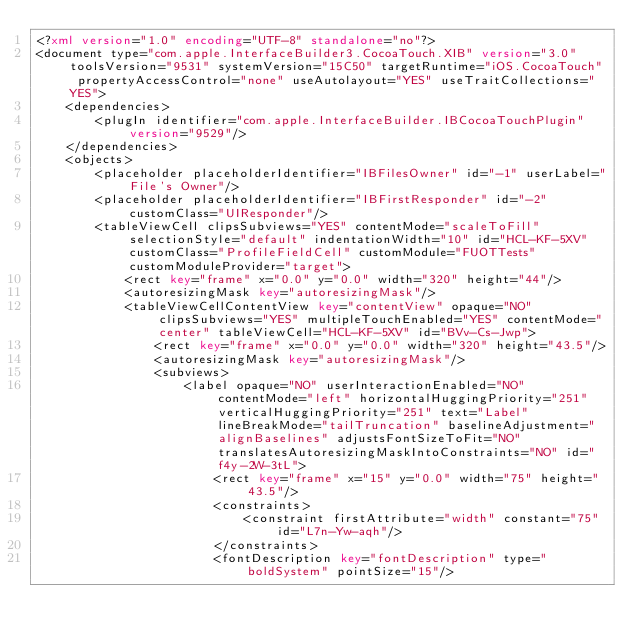Convert code to text. <code><loc_0><loc_0><loc_500><loc_500><_XML_><?xml version="1.0" encoding="UTF-8" standalone="no"?>
<document type="com.apple.InterfaceBuilder3.CocoaTouch.XIB" version="3.0" toolsVersion="9531" systemVersion="15C50" targetRuntime="iOS.CocoaTouch" propertyAccessControl="none" useAutolayout="YES" useTraitCollections="YES">
    <dependencies>
        <plugIn identifier="com.apple.InterfaceBuilder.IBCocoaTouchPlugin" version="9529"/>
    </dependencies>
    <objects>
        <placeholder placeholderIdentifier="IBFilesOwner" id="-1" userLabel="File's Owner"/>
        <placeholder placeholderIdentifier="IBFirstResponder" id="-2" customClass="UIResponder"/>
        <tableViewCell clipsSubviews="YES" contentMode="scaleToFill" selectionStyle="default" indentationWidth="10" id="HCL-KF-5XV" customClass="ProfileFieldCell" customModule="FUOTTests" customModuleProvider="target">
            <rect key="frame" x="0.0" y="0.0" width="320" height="44"/>
            <autoresizingMask key="autoresizingMask"/>
            <tableViewCellContentView key="contentView" opaque="NO" clipsSubviews="YES" multipleTouchEnabled="YES" contentMode="center" tableViewCell="HCL-KF-5XV" id="BVv-Cs-Jwp">
                <rect key="frame" x="0.0" y="0.0" width="320" height="43.5"/>
                <autoresizingMask key="autoresizingMask"/>
                <subviews>
                    <label opaque="NO" userInteractionEnabled="NO" contentMode="left" horizontalHuggingPriority="251" verticalHuggingPriority="251" text="Label" lineBreakMode="tailTruncation" baselineAdjustment="alignBaselines" adjustsFontSizeToFit="NO" translatesAutoresizingMaskIntoConstraints="NO" id="f4y-2W-3tL">
                        <rect key="frame" x="15" y="0.0" width="75" height="43.5"/>
                        <constraints>
                            <constraint firstAttribute="width" constant="75" id="L7n-Yw-aqh"/>
                        </constraints>
                        <fontDescription key="fontDescription" type="boldSystem" pointSize="15"/></code> 